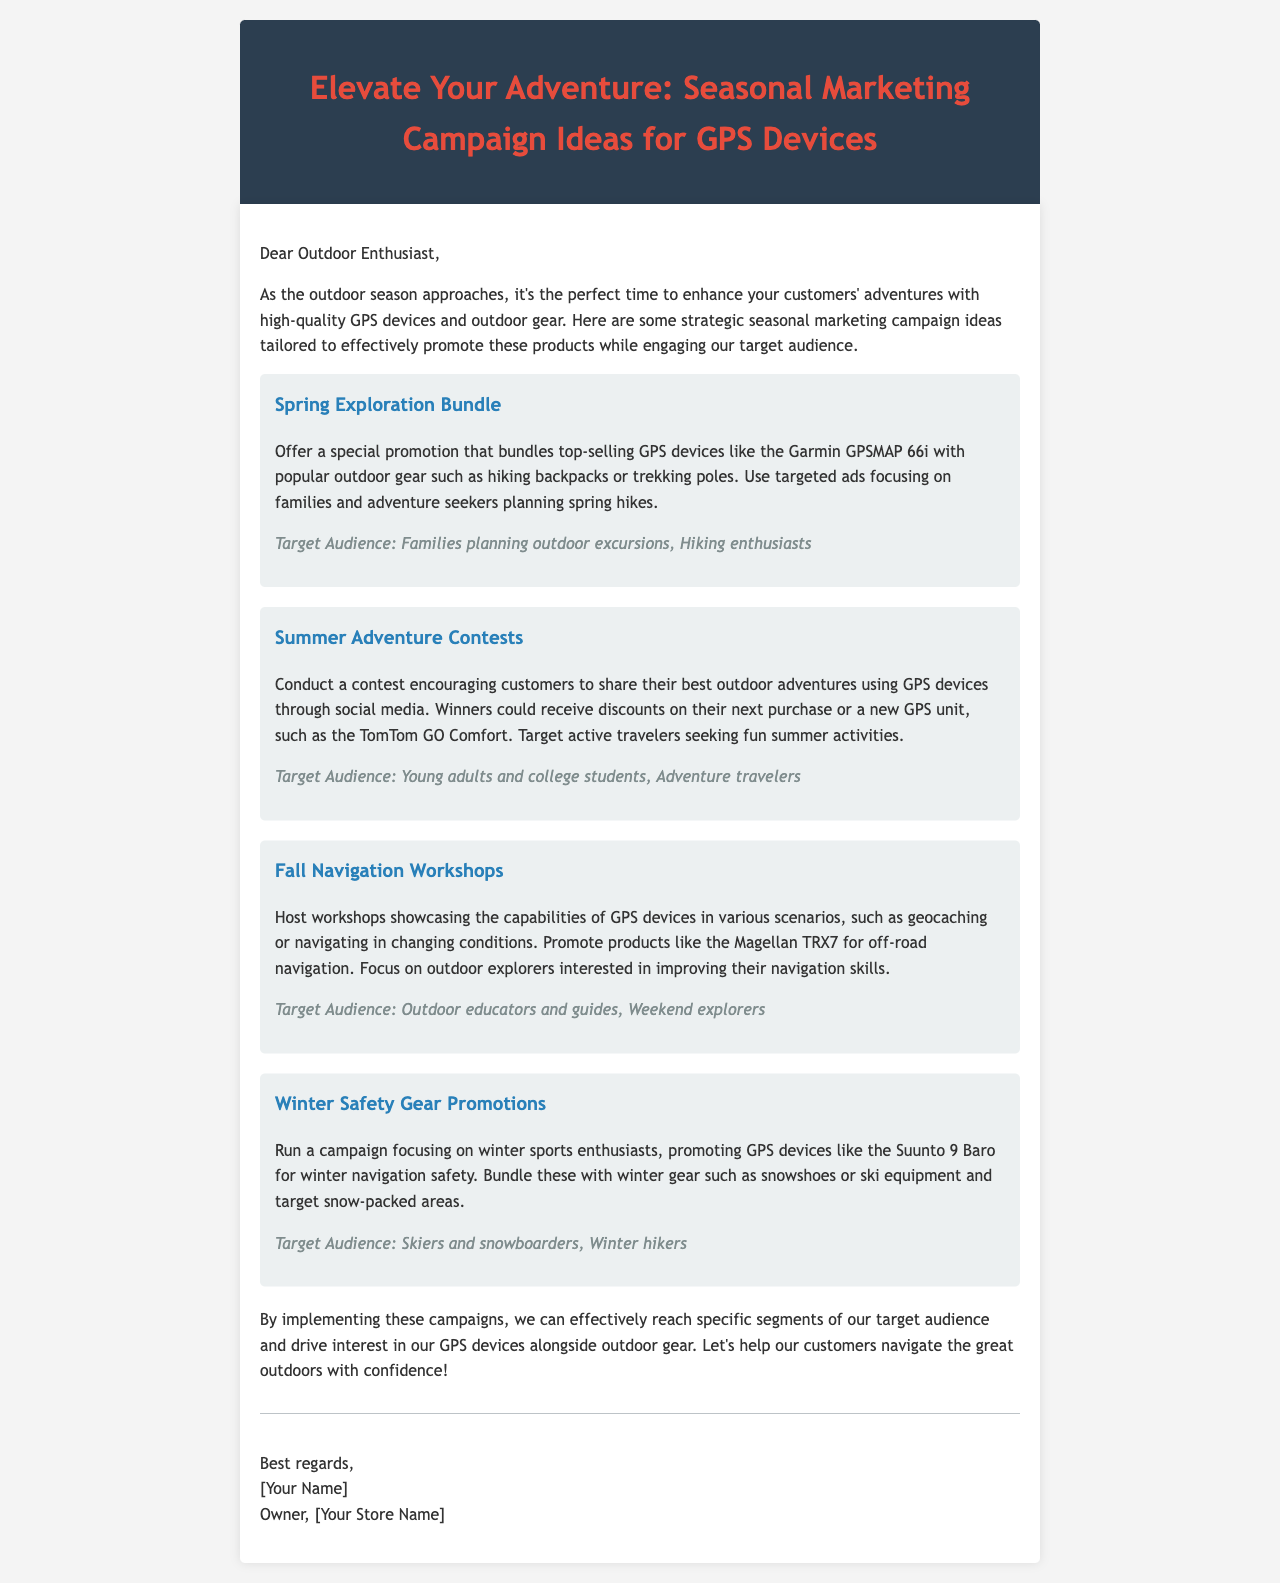What is the title of the document? The title is included in the header of the document, emphasizing the seasonal marketing campaign ideas for GPS devices.
Answer: Elevate Your Adventure: Seasonal Marketing Campaign Ideas for GPS Devices How many seasonal campaign ideas are presented? The document lists four different seasonal marketing campaign ideas for promoting GPS devices.
Answer: Four What GPS device is mentioned in the Spring Exploration Bundle? The Spring Exploration Bundle specifically mentions the Garmin GPSMAP 66i as part of the promotion.
Answer: Garmin GPSMAP 66i Who is the target audience for the Winter Safety Gear Promotions? The document lists specific target audiences for each campaign, indicating that the Winter Safety Gear Promotions target skiers and snowboarders.
Answer: Skiers and snowboarders What type of event is suggested for the Fall Navigation Workshops? The document proposes hosting workshops to showcase the capabilities of GPS devices in various outdoor scenarios.
Answer: Workshops Which social media activity is included in the Summer Adventure Contests? The Summer Adventure Contests encourage customers to share their best outdoor adventures using GPS devices through social media.
Answer: Share adventures What is the focus of the campaign during winter according to the document? The winter campaign specifically emphasizes promoting navigation safety for winter sports enthusiasts.
Answer: Winter sports safety 